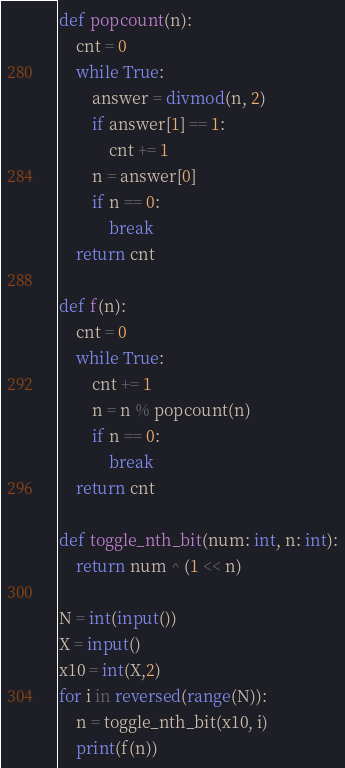Convert code to text. <code><loc_0><loc_0><loc_500><loc_500><_Python_>def popcount(n):
    cnt = 0
    while True:
        answer = divmod(n, 2)
        if answer[1] == 1:
            cnt += 1
        n = answer[0]
        if n == 0:
            break
    return cnt

def f(n):
    cnt = 0
    while True:
        cnt += 1
        n = n % popcount(n)
        if n == 0:
            break
    return cnt

def toggle_nth_bit(num: int, n: int):
    return num ^ (1 << n)

N = int(input())
X = input()
x10 = int(X,2)
for i in reversed(range(N)):
    n = toggle_nth_bit(x10, i)
    print(f(n))</code> 